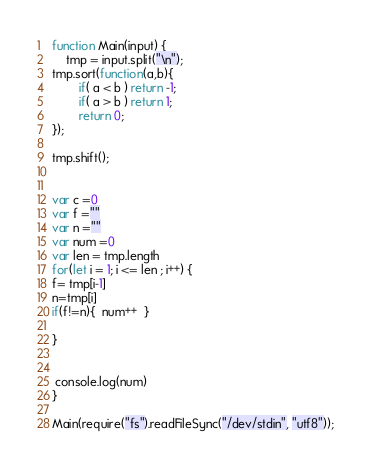Convert code to text. <code><loc_0><loc_0><loc_500><loc_500><_JavaScript_>function Main(input) {
	tmp = input.split("\n");
tmp.sort(function(a,b){
        if( a < b ) return -1;
        if( a > b ) return 1;
        return 0;
});
	
tmp.shift();


var c =0
var f =""
var n =""
var num =0
var len = tmp.length
for(let i = 1; i <= len ; i++) {
f= tmp[i-1]
n=tmp[i]
if(f!=n){  num++  }

}


 console.log(num)
}

Main(require("fs").readFileSync("/dev/stdin", "utf8"));</code> 